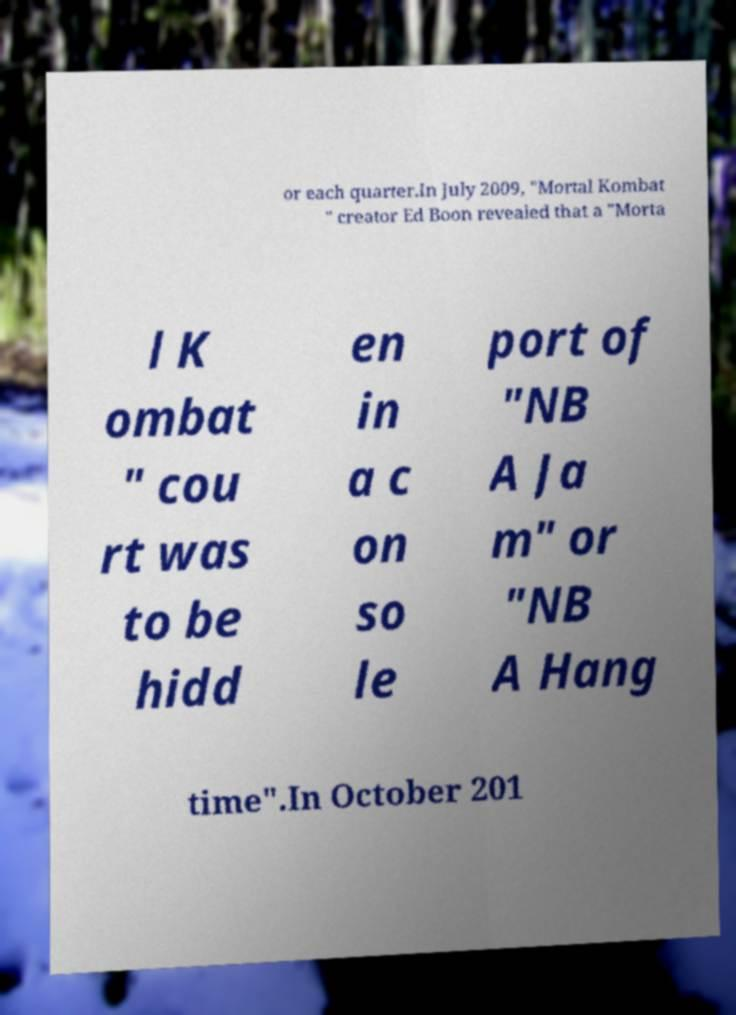Can you read and provide the text displayed in the image?This photo seems to have some interesting text. Can you extract and type it out for me? or each quarter.In July 2009, "Mortal Kombat " creator Ed Boon revealed that a "Morta l K ombat " cou rt was to be hidd en in a c on so le port of "NB A Ja m" or "NB A Hang time".In October 201 